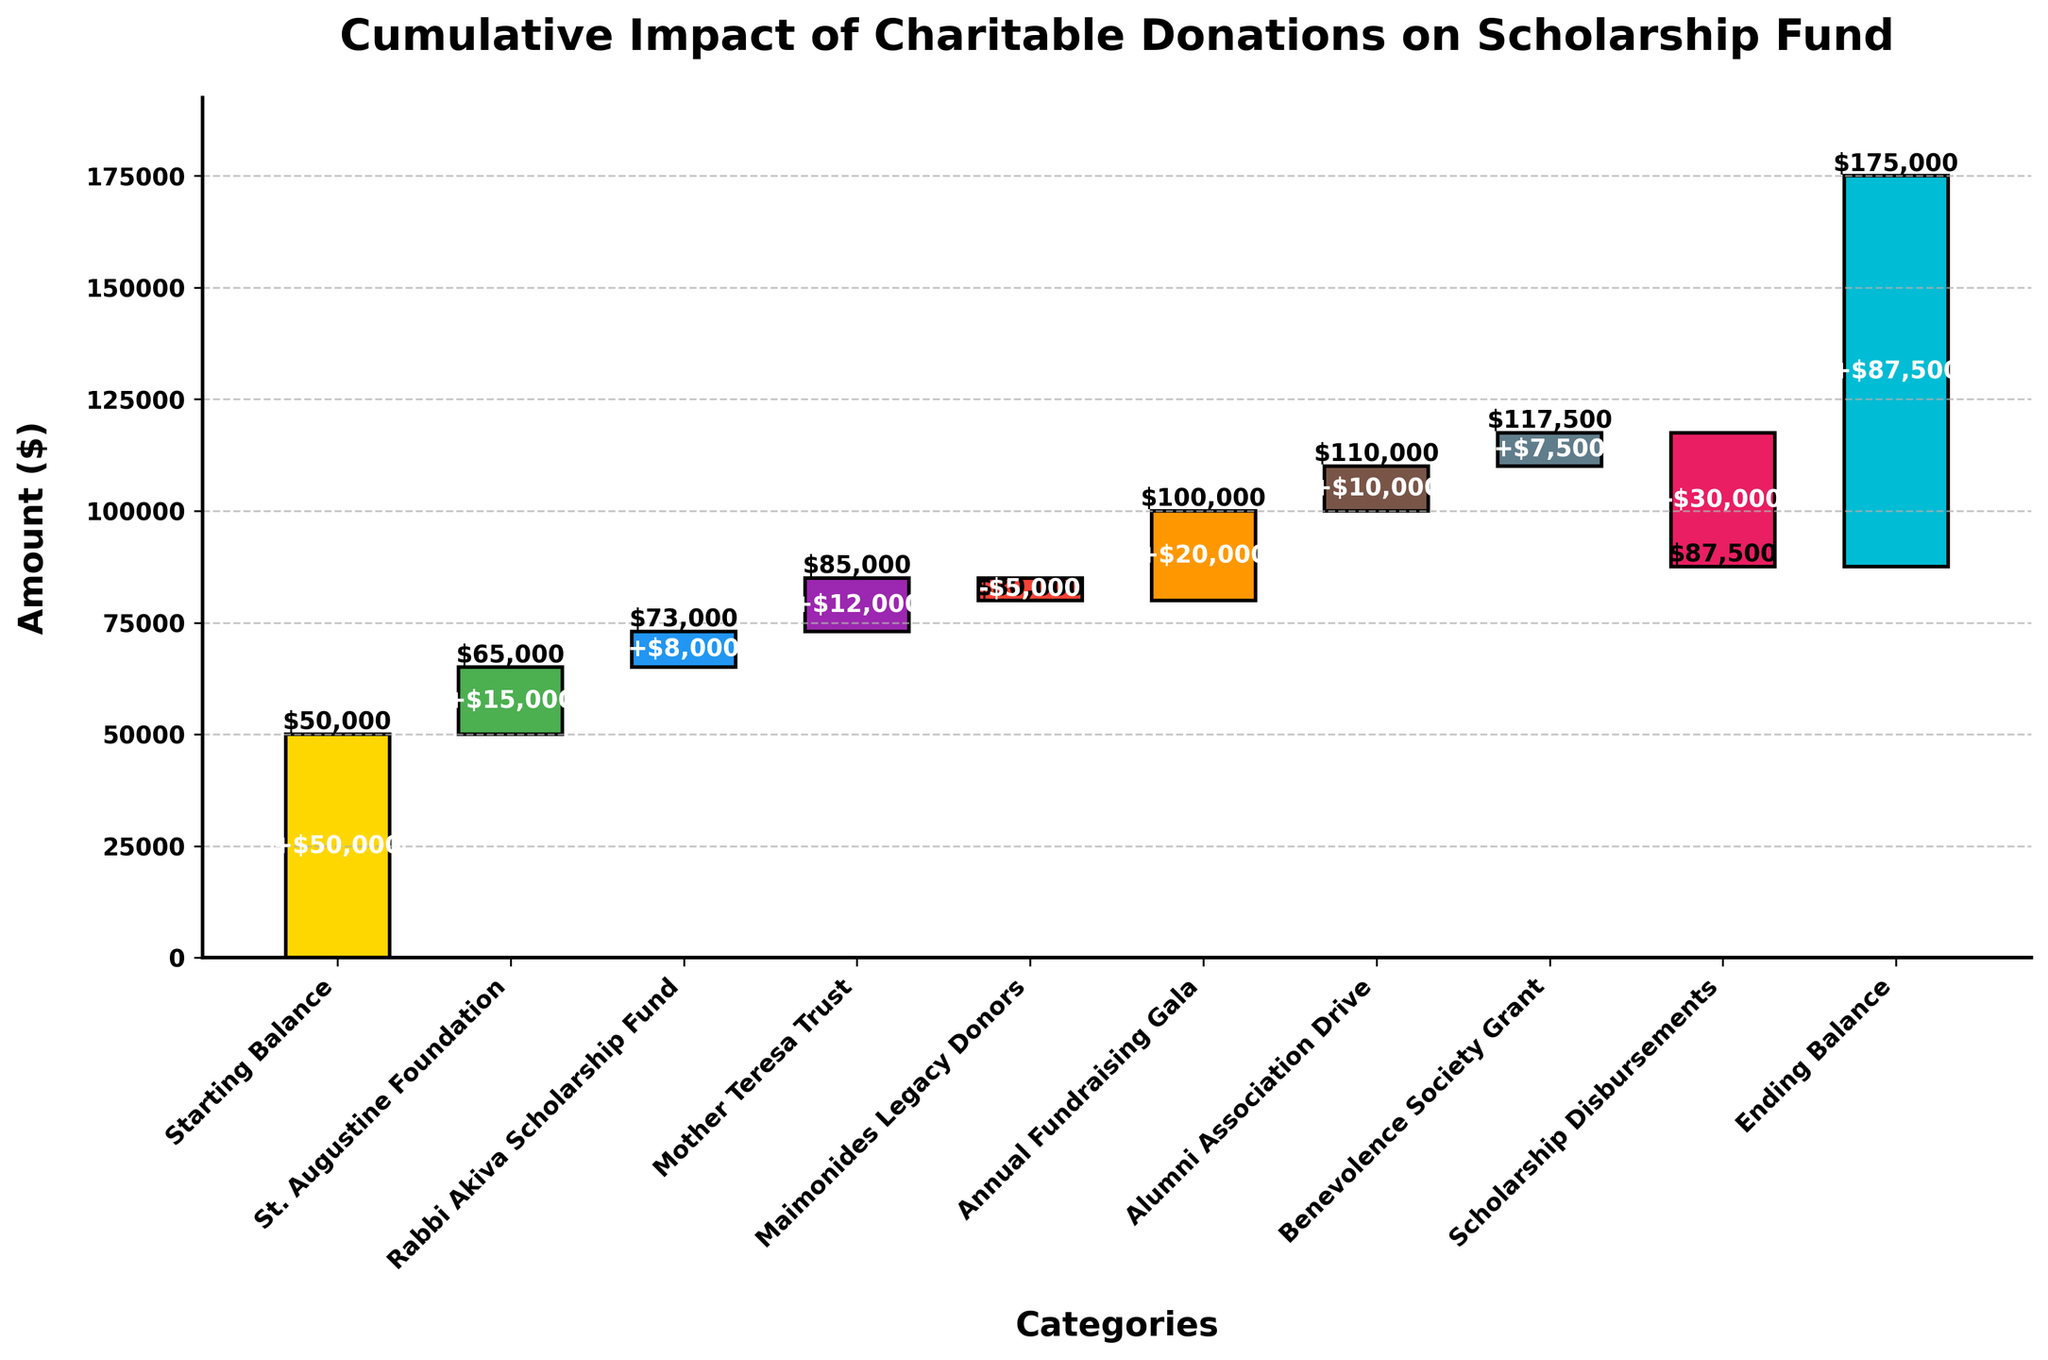What is the title of the chart? The title is located at the top of the chart and it reads: "Cumulative Impact of Charitable Donations on Scholarship Fund"
Answer: Cumulative Impact of Charitable Donations on Scholarship Fund What is the starting balance of the scholarship fund? The starting balance is the first category in the waterfall chart, which shows the initial amount before any donations or disbursements.
Answer: $50,000 Which category had the highest positive impact on the scholarship fund? By observing the bars in the chart, the category with the highest positive value (the tallest bar going upwards) is identified.
Answer: Annual Fundraising Gala What is the cumulative balance after the Mother Teresa Trust donation? To find this, look at the cumulative amount after the bar representing Mother Teresa Trust. This is the sum of the starting balance and the values of previous donations.
Answer: $85,000 What is the total amount of scholarship disbursements? The total amount of scholarship disbursements can be found by identifying the category with a negative value and reading off the value assigned to it.
Answer: $30,000 What is the net change in the scholarship fund from the starting to the ending balance? Subtract the starting balance from the ending balance to determine the net change: $87,500 (ending) - $50,000 (starting).
Answer: $37,500 How do the cumulative impacts from St. Augustine Foundation and Rabbi Akiva Scholarship Fund compare? Look at the heights of the bars for both categories and compare their cumulative impacts to see which one contributes more to the total.
Answer: St. Augustine Foundation has a higher impact What is the cumulative balance of the fund before and after accounting for the Maimonides Legacy Donors? The cumulative balance before the Maimonides Legacy Donors is the sum of the previous categories. The balance after is obtained by applying the negative impact of Maimonides Legacy Donors.
Answer: $85,000 before; $80,000 after How much did the Alumni Association Drive contribute to the scholarship fund? Look at the value associated with the Alumni Association Drive bar, which indicates the amount contributed by this category.
Answer: $10,000 Which category had a negative impact on the scholarship fund and by how much? Identify the bars with negative values and read off the category names and values. The Maimonides Legacy Donors and Scholarship Disbursements both have negative impacts.
Answer: Maimonides Legacy Donors: $5,000, Scholarship Disbursements: $30,000 